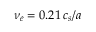<formula> <loc_0><loc_0><loc_500><loc_500>\nu _ { e } = 0 . 2 1 \, c _ { s } / a</formula> 